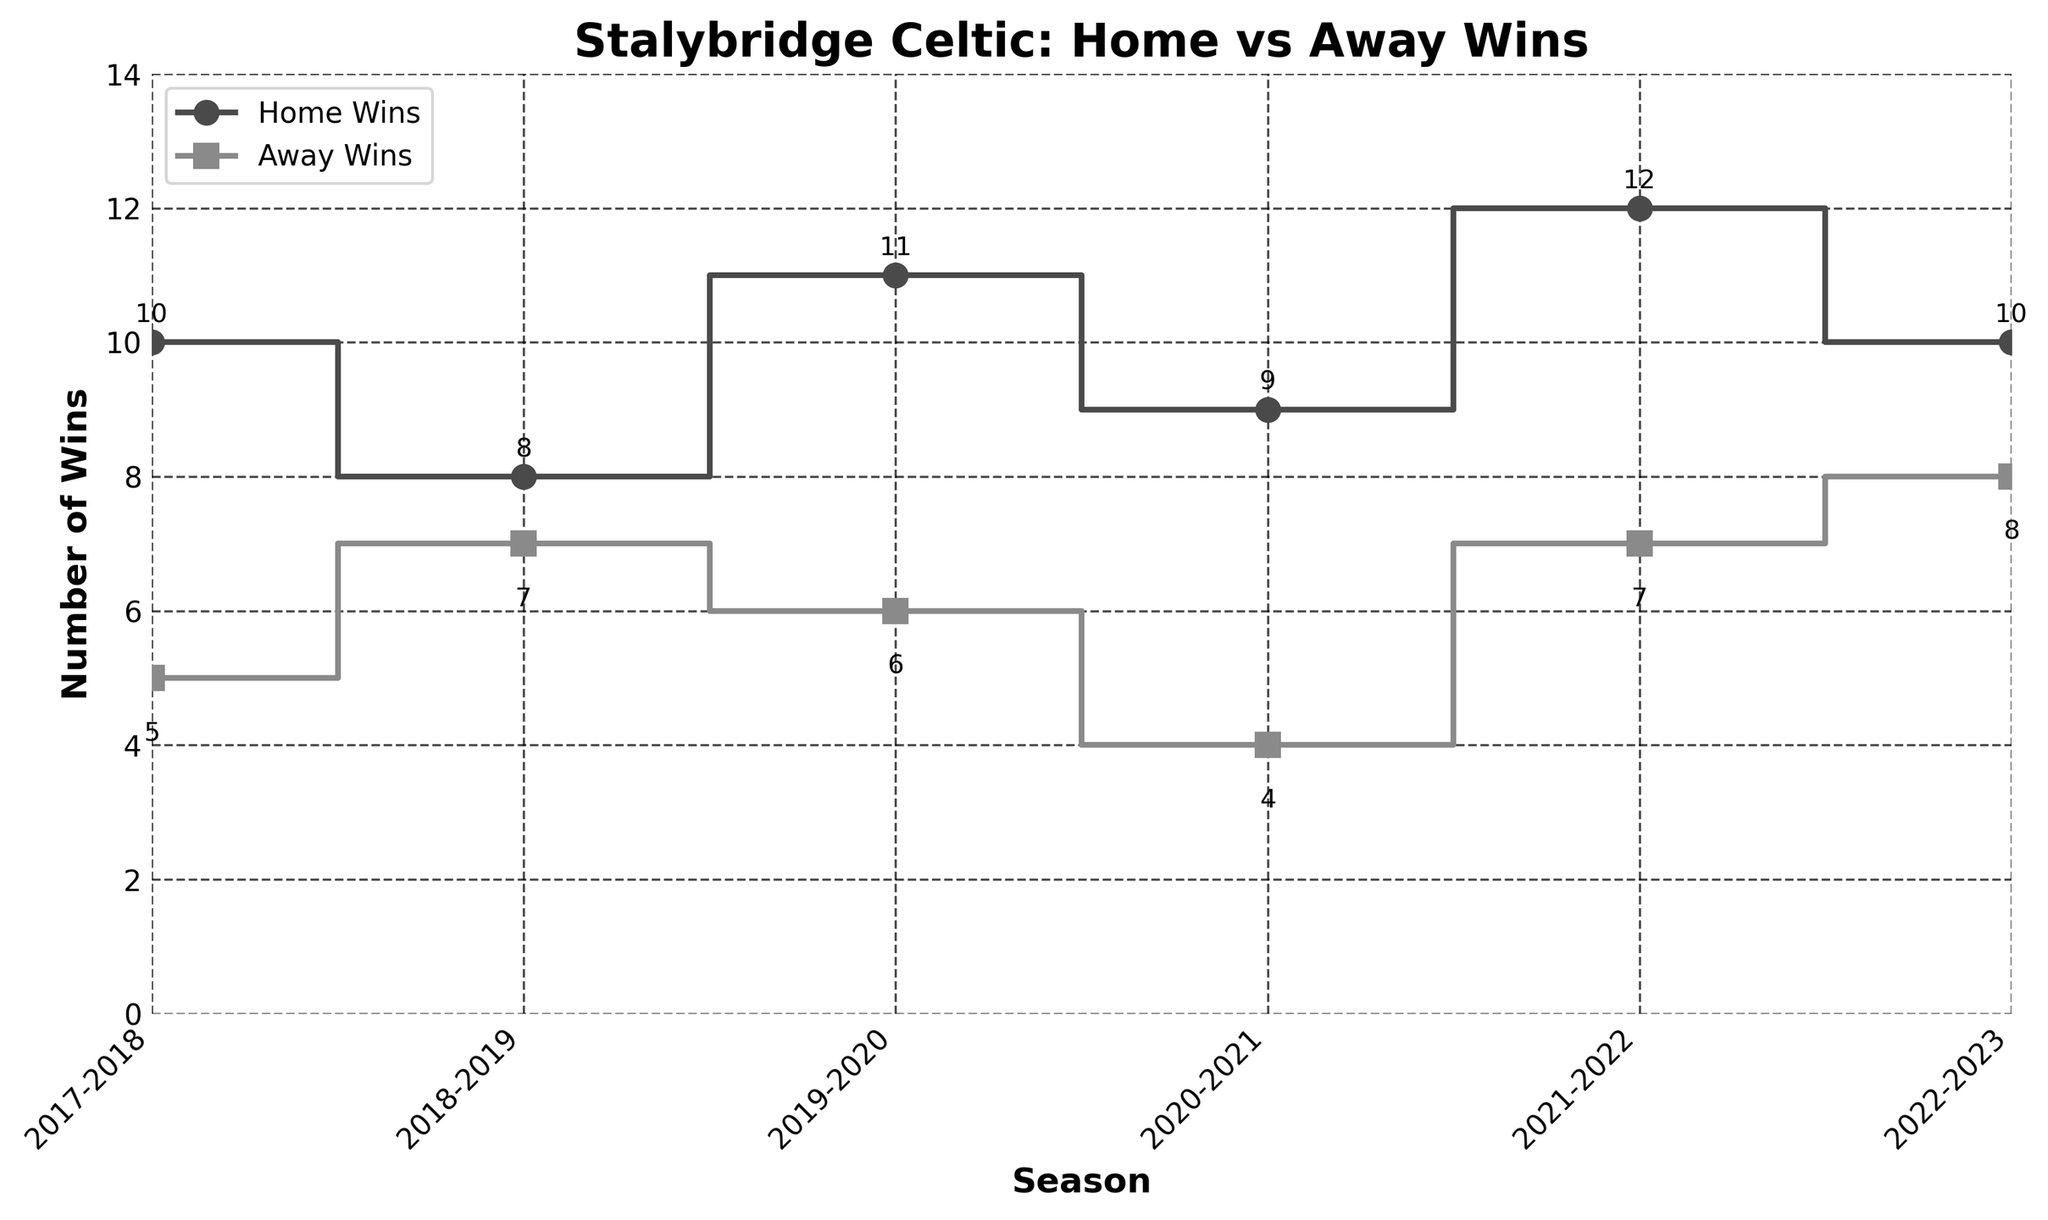What's the title of the plot? The plot title is prominently displayed at the top of the figure. It reads "Stalybridge Celtic: Home vs Away Wins"
Answer: Stalybridge Celtic: Home vs Away Wins What is the highest number of home wins in a season? The highest number of home wins can be identified as the tallest marker on the 'Home Wins' line. This occurs in the 2021-2022 season with 12 wins
Answer: 12 Which season had the lowest number of away wins? By comparing the markers on the 'Away Wins' line, the lowest point is in the 2020-2021 season with 4 away wins
Answer: 2020-2021 What are the home and away wins for the 2018-2019 season? Locate the markers corresponding to the 2018-2019 season and read the values. The 'Home Wins' line shows 8 and 'Away Wins' line shows 7 for that season
Answer: Home: 8, Away: 7 How did the home wins change from the 2020-2021 season to the 2021-2022 season? Compare the markers for 'Home Wins' in these two seasons. They increased from 9 in 2020-2021 to 12 in 2021-2022
Answer: Increased by 3 Which season had the same number of home and away wins? Check the plot for any overlapping markers for 'Home Wins' and 'Away Wins'. In the 2022-2023 season, both lines show 10 wins
Answer: 2022-2023 What's the total number of wins (home and away) in the 2019-2020 season? Add the 'Home Wins' and 'Away Wins' values for the 2019-2020 season: 11 + 6 = 17
Answer: 17 Which type of wins (home or away) was more consistent over the seasons? Compare the fluctuations in 'Home Wins' and 'Away Wins'. The 'Away Wins' line shows smaller fluctuations compared to 'Home Wins'
Answer: Away Wins What's the average number of away wins per season across the given data? Sum up the 'Away Wins' across all seasons and divide by the number of seasons: (5+7+6+4+7+8)/6 = 6.167
Answer: 6.167 Between which two consecutive seasons was the biggest change in home wins observed? Look at the differences between consecutive points on the 'Home Wins' line. The biggest change occurs between 2020-2021 (9 wins) and 2021-2022 (12 wins), so the change is 12 - 9 = 3
Answer: Between 2020-2021 and 2021-2022 (3 wins) 